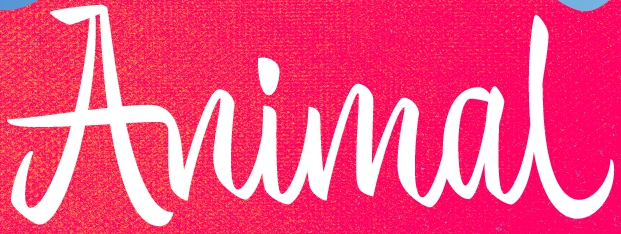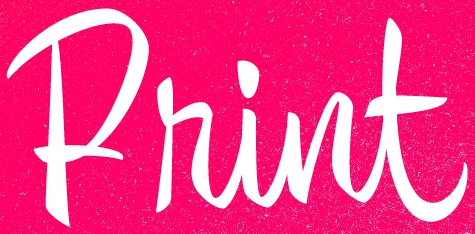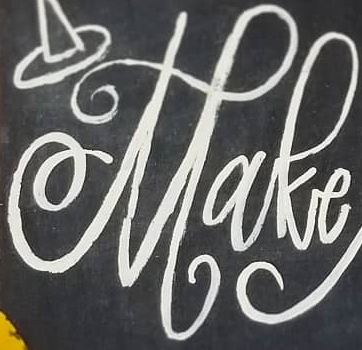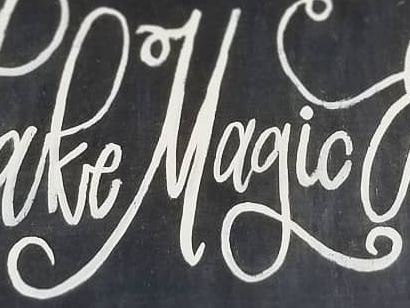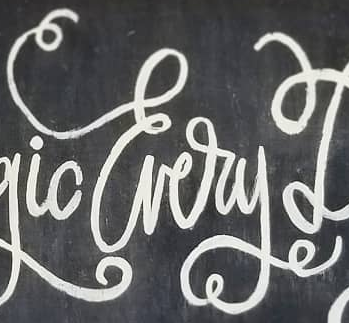Identify the words shown in these images in order, separated by a semicolon. Animal; Print; Make; Magic; Every 